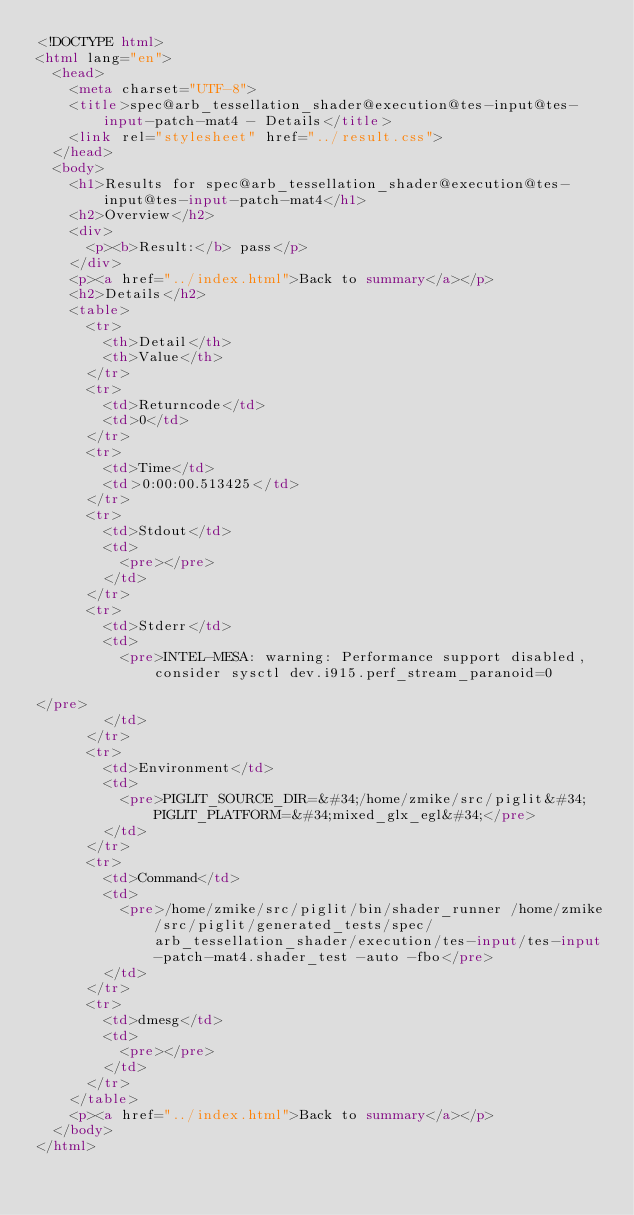Convert code to text. <code><loc_0><loc_0><loc_500><loc_500><_HTML_><!DOCTYPE html>
<html lang="en">
  <head>
    <meta charset="UTF-8">
    <title>spec@arb_tessellation_shader@execution@tes-input@tes-input-patch-mat4 - Details</title>
    <link rel="stylesheet" href="../result.css">
  </head>
  <body>
    <h1>Results for spec@arb_tessellation_shader@execution@tes-input@tes-input-patch-mat4</h1>
    <h2>Overview</h2>
    <div>
      <p><b>Result:</b> pass</p>
    </div>
    <p><a href="../index.html">Back to summary</a></p>
    <h2>Details</h2>
    <table>
      <tr>
        <th>Detail</th>
        <th>Value</th>
      </tr>
      <tr>
        <td>Returncode</td>
        <td>0</td>
      </tr>
      <tr>
        <td>Time</td>
        <td>0:00:00.513425</td>
      </tr>
      <tr>
        <td>Stdout</td>
        <td>
          <pre></pre>
        </td>
      </tr>
      <tr>
        <td>Stderr</td>
        <td>
          <pre>INTEL-MESA: warning: Performance support disabled, consider sysctl dev.i915.perf_stream_paranoid=0

</pre>
        </td>
      </tr>
      <tr>
        <td>Environment</td>
        <td>
          <pre>PIGLIT_SOURCE_DIR=&#34;/home/zmike/src/piglit&#34; PIGLIT_PLATFORM=&#34;mixed_glx_egl&#34;</pre>
        </td>
      </tr>
      <tr>
        <td>Command</td>
        <td>
          <pre>/home/zmike/src/piglit/bin/shader_runner /home/zmike/src/piglit/generated_tests/spec/arb_tessellation_shader/execution/tes-input/tes-input-patch-mat4.shader_test -auto -fbo</pre>
        </td>
      </tr>
      <tr>
        <td>dmesg</td>
        <td>
          <pre></pre>
        </td>
      </tr>
    </table>
    <p><a href="../index.html">Back to summary</a></p>
  </body>
</html>
</code> 